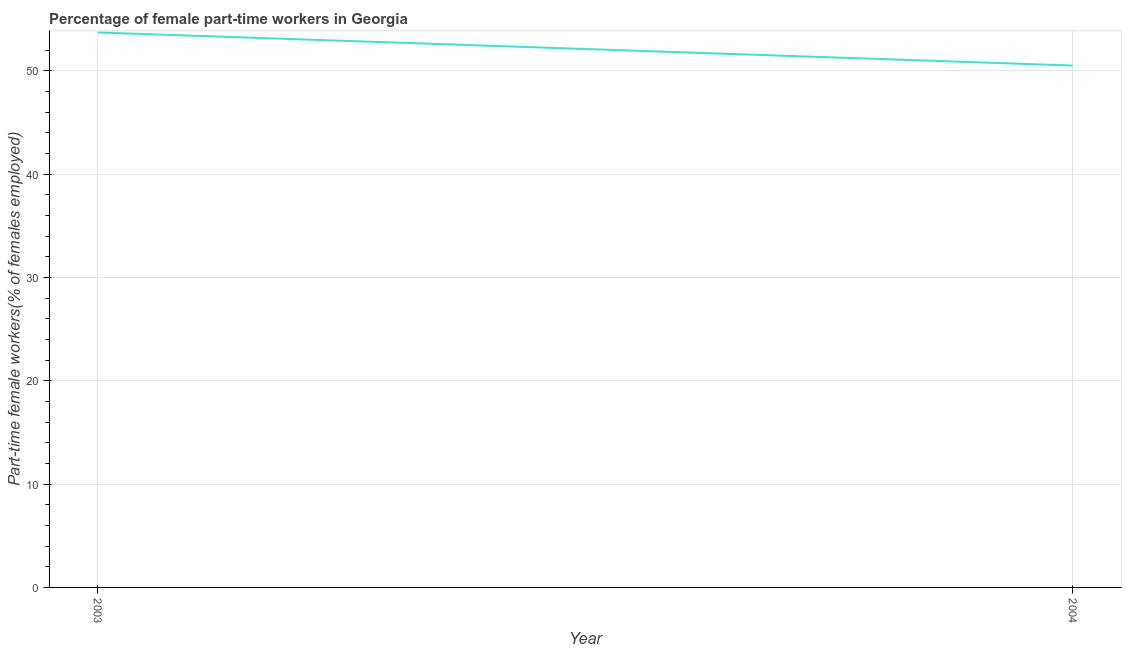What is the percentage of part-time female workers in 2003?
Provide a succinct answer. 53.7. Across all years, what is the maximum percentage of part-time female workers?
Your answer should be compact. 53.7. Across all years, what is the minimum percentage of part-time female workers?
Make the answer very short. 50.5. In which year was the percentage of part-time female workers maximum?
Your response must be concise. 2003. What is the sum of the percentage of part-time female workers?
Provide a short and direct response. 104.2. What is the difference between the percentage of part-time female workers in 2003 and 2004?
Keep it short and to the point. 3.2. What is the average percentage of part-time female workers per year?
Offer a terse response. 52.1. What is the median percentage of part-time female workers?
Your answer should be compact. 52.1. In how many years, is the percentage of part-time female workers greater than 40 %?
Your answer should be compact. 2. Do a majority of the years between 2004 and 2003 (inclusive) have percentage of part-time female workers greater than 32 %?
Provide a succinct answer. No. What is the ratio of the percentage of part-time female workers in 2003 to that in 2004?
Provide a short and direct response. 1.06. Is the percentage of part-time female workers in 2003 less than that in 2004?
Your response must be concise. No. Does the percentage of part-time female workers monotonically increase over the years?
Provide a succinct answer. No. What is the difference between two consecutive major ticks on the Y-axis?
Give a very brief answer. 10. Are the values on the major ticks of Y-axis written in scientific E-notation?
Ensure brevity in your answer.  No. Does the graph contain any zero values?
Make the answer very short. No. Does the graph contain grids?
Your response must be concise. Yes. What is the title of the graph?
Your answer should be very brief. Percentage of female part-time workers in Georgia. What is the label or title of the Y-axis?
Offer a very short reply. Part-time female workers(% of females employed). What is the Part-time female workers(% of females employed) in 2003?
Ensure brevity in your answer.  53.7. What is the Part-time female workers(% of females employed) in 2004?
Offer a very short reply. 50.5. What is the difference between the Part-time female workers(% of females employed) in 2003 and 2004?
Give a very brief answer. 3.2. What is the ratio of the Part-time female workers(% of females employed) in 2003 to that in 2004?
Your response must be concise. 1.06. 